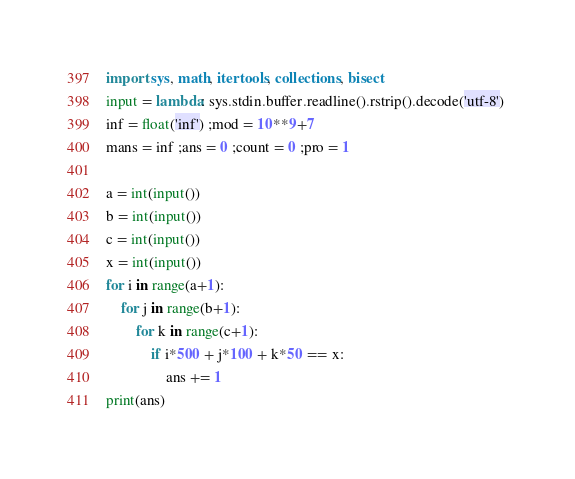<code> <loc_0><loc_0><loc_500><loc_500><_Python_>import sys, math, itertools, collections, bisect 
input = lambda: sys.stdin.buffer.readline().rstrip().decode('utf-8') 
inf = float('inf') ;mod = 10**9+7 
mans = inf ;ans = 0 ;count = 0 ;pro = 1

a = int(input())
b = int(input())
c = int(input())
x = int(input())
for i in range(a+1):
    for j in range(b+1):
        for k in range(c+1):
            if i*500 + j*100 + k*50 == x:
                ans += 1
print(ans)</code> 